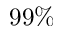<formula> <loc_0><loc_0><loc_500><loc_500>9 9 \%</formula> 